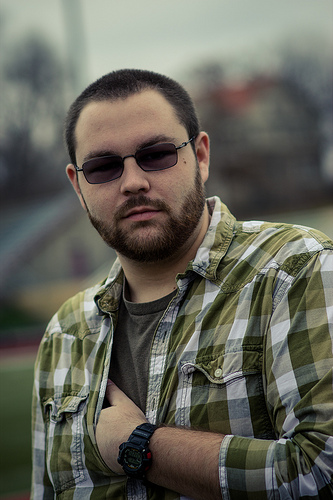<image>
Can you confirm if the man is on the glasses? No. The man is not positioned on the glasses. They may be near each other, but the man is not supported by or resting on top of the glasses. Where is the glasses in relation to the shirt? Is it next to the shirt? No. The glasses is not positioned next to the shirt. They are located in different areas of the scene. Where is the glasses in relation to the shirt? Is it above the shirt? Yes. The glasses is positioned above the shirt in the vertical space, higher up in the scene. 